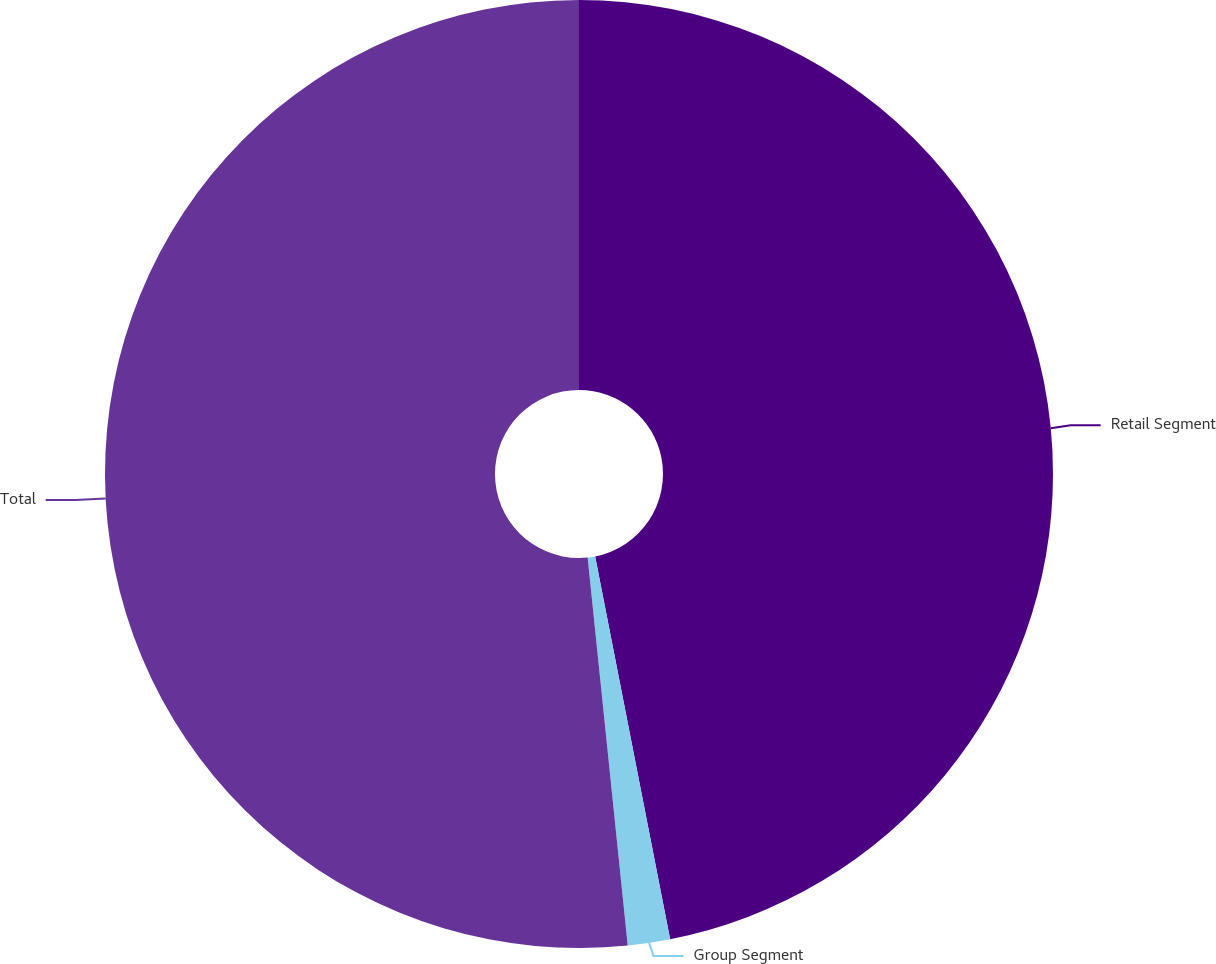Convert chart to OTSL. <chart><loc_0><loc_0><loc_500><loc_500><pie_chart><fcel>Retail Segment<fcel>Group Segment<fcel>Total<nl><fcel>46.92%<fcel>1.44%<fcel>51.64%<nl></chart> 